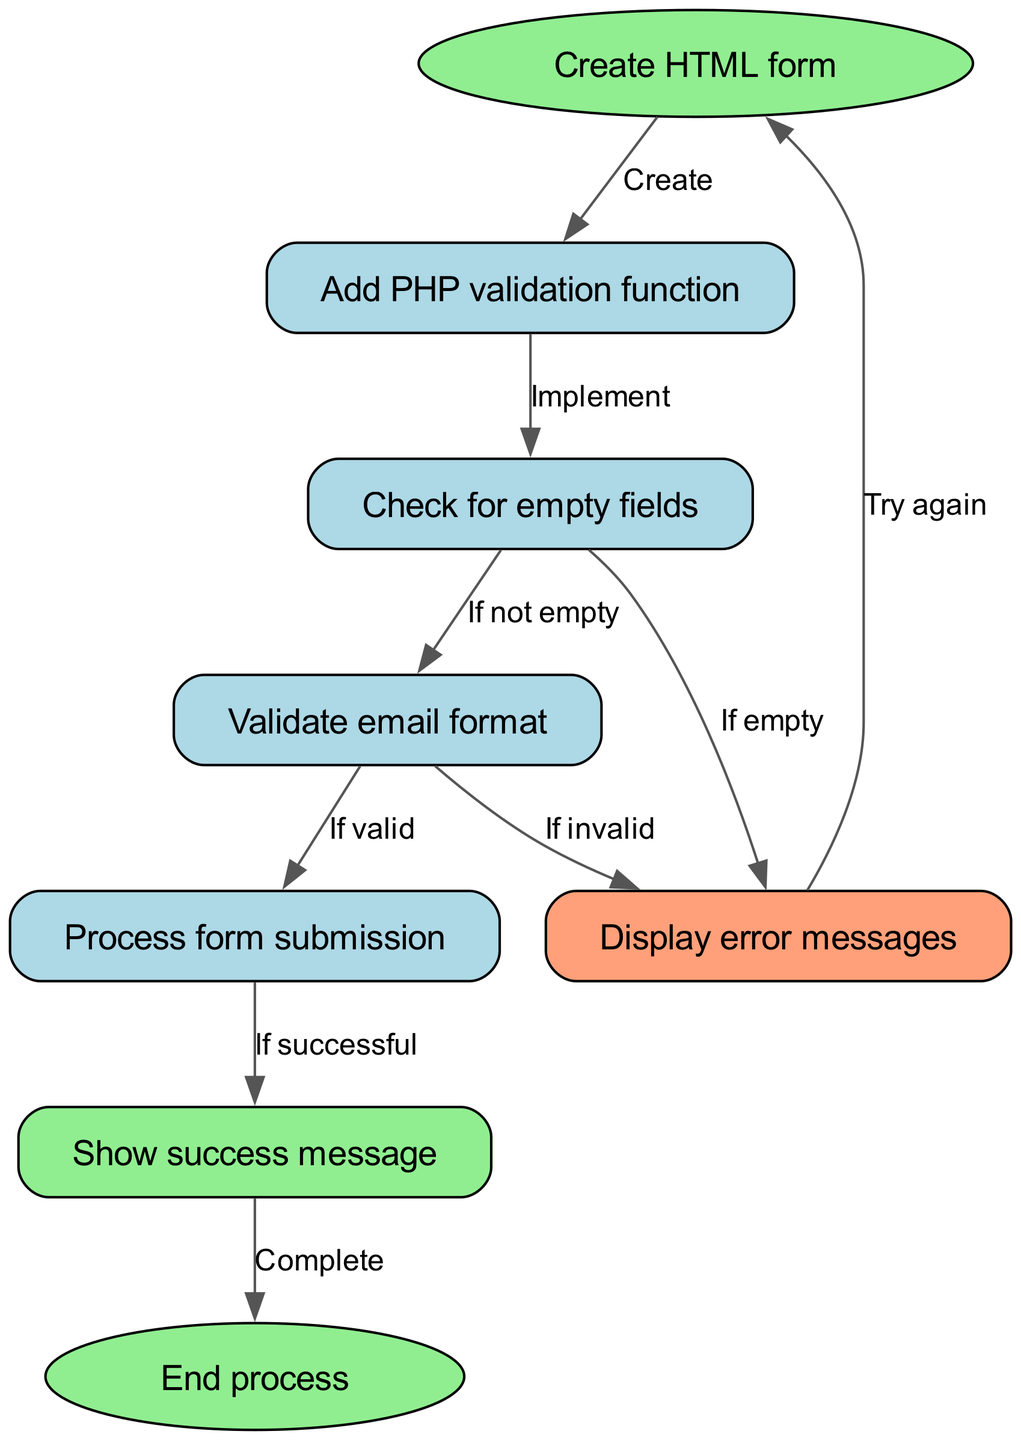What is the first step in the process? The diagram starts with the node labeled "Create HTML form," which indicates that this is the first step in the instruction flow.
Answer: Create HTML form Which node indicates a validation function? The node that represents the validation function is labeled "Add PHP validation function," which clearly names this step in the process.
Answer: Add PHP validation function How many checks are performed before processing the form? The diagram shows two checks: "Check for empty fields" and "Validate email format." This indicates that the process involves these two validation steps before form processing.
Answer: 2 What happens if any fields are empty? According to the diagram, if there are empty fields, the flow goes to the "Display error messages" node, indicating that error messages will be shown for empty fields.
Answer: Display error messages If the email format is invalid, what is shown next? The diagram shows that if the email is invalid, the flow leads to "Display error messages," meaning an error message about the invalid email format will be shown next.
Answer: Display error messages What node is reached if the process form submission is successful? The flow indicates that if the form submission is successful, the next node reached is "Show success message," which confirms the success of the submission.
Answer: Show success message How many total nodes are there in the diagram? The diagram lists eight distinct nodes involved in the process. This includes all steps from the start to the end, which totals to eight nodes.
Answer: 8 What is the ending state of this process? The process concludes at the "End process" node, which signifies the termination of the flow in this diagram.
Answer: End process What action follows if there are errors in the validation? If errors are found during validation (either empty fields or invalid email), the diagram indicates that the flow loops back to the "Create HTML form" node for a retry.
Answer: Try again 